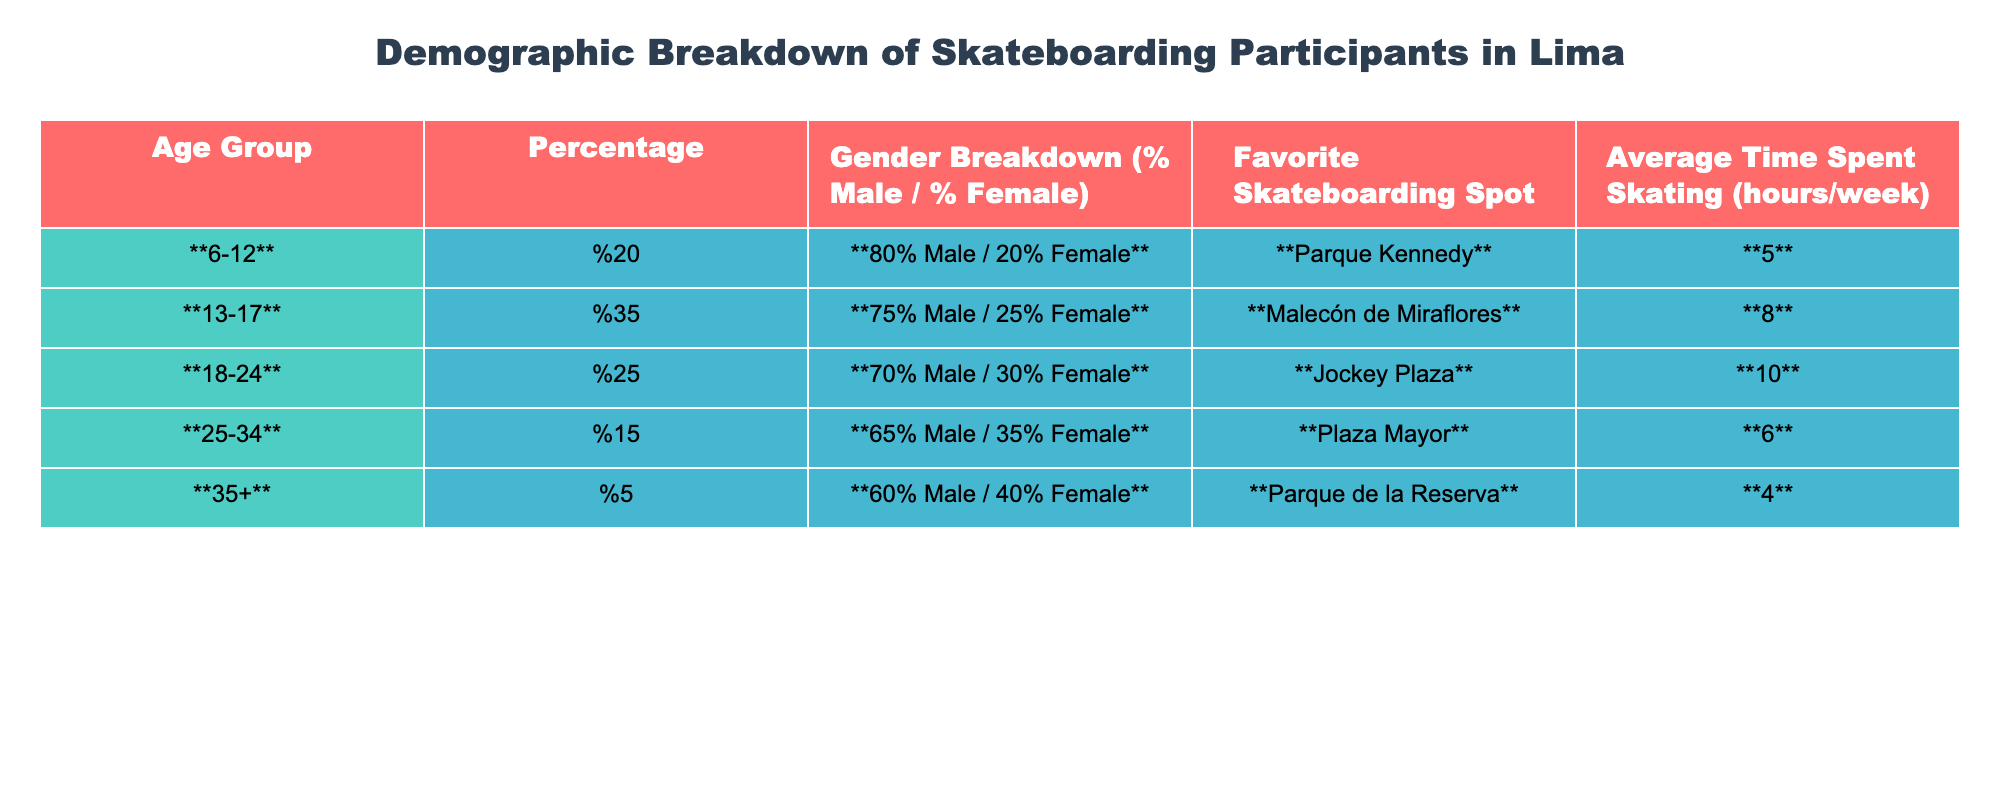What percentage of skateboarding participants are between the ages of 6-12? The table shows that the age group 6-12 has a percentage of 20%.
Answer: 20% What is the favorite skateboarding spot for participants aged 18-24? According to the table, the favorite spot for the 18-24 age group is Jockey Plaza.
Answer: Jockey Plaza Which age group has the highest percentage of female participants? The age group 35+ has a percentage of 40% female participants, which is the highest among all age groups.
Answer: 35+ How much average time do participants aged 13-17 spend skating weekly? The table indicates that participants in the 13-17 age group spend an average of 8 hours skating per week.
Answer: 8 hours Is the percentage of male participants in the 25-34 age group higher than 60%? Yes, the table shows that the percentage of male participants in the 25-34 age group is 65%, which is indeed higher than 60%.
Answer: Yes What is the average percentage of male participants across all age groups? The percentages for male participants across age groups are: 80, 75, 70, 65, and 60. The average is calculated as (80 + 75 + 70 + 65 + 60) / 5 = 64%
Answer: 64% If we combine the age groups 6-12 and 13-17, what percentage of participants are male? The combined male percentages for these age groups are 80% (6-12) and 75% (13-17). To find the overall percentage: (20%*80 + 35%*75) / (20% + 35%) = 77.14% (rounded to 77%).
Answer: 77% Which age group spends the least amount of time skating on average? The 35+ age group has the lowest average time spent skating, with just 4 hours per week.
Answer: 4 hours Are the majority of skateboarding participants male or female in the 18-24 age group? In the 18-24 age group, there are 70% male participants, which indicates that the majority are male.
Answer: Male What is the total percentage of skateboarding participants in the age group 25-34 and 35+ combined? Adding the percentages for the age groups 25-34 (15%) and 35+ (5%) gives a total of 20%.
Answer: 20% 